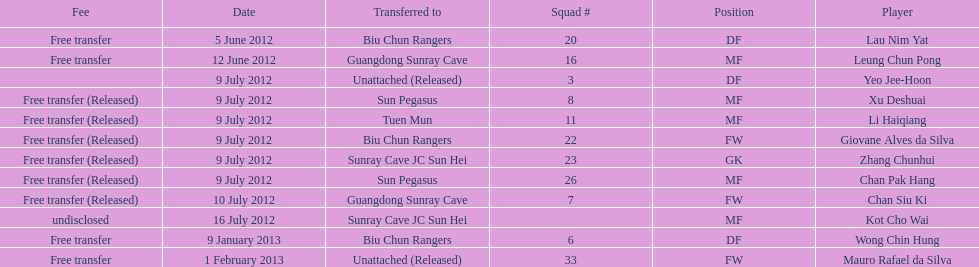What squad # is listed previous to squad # 7? 26. 